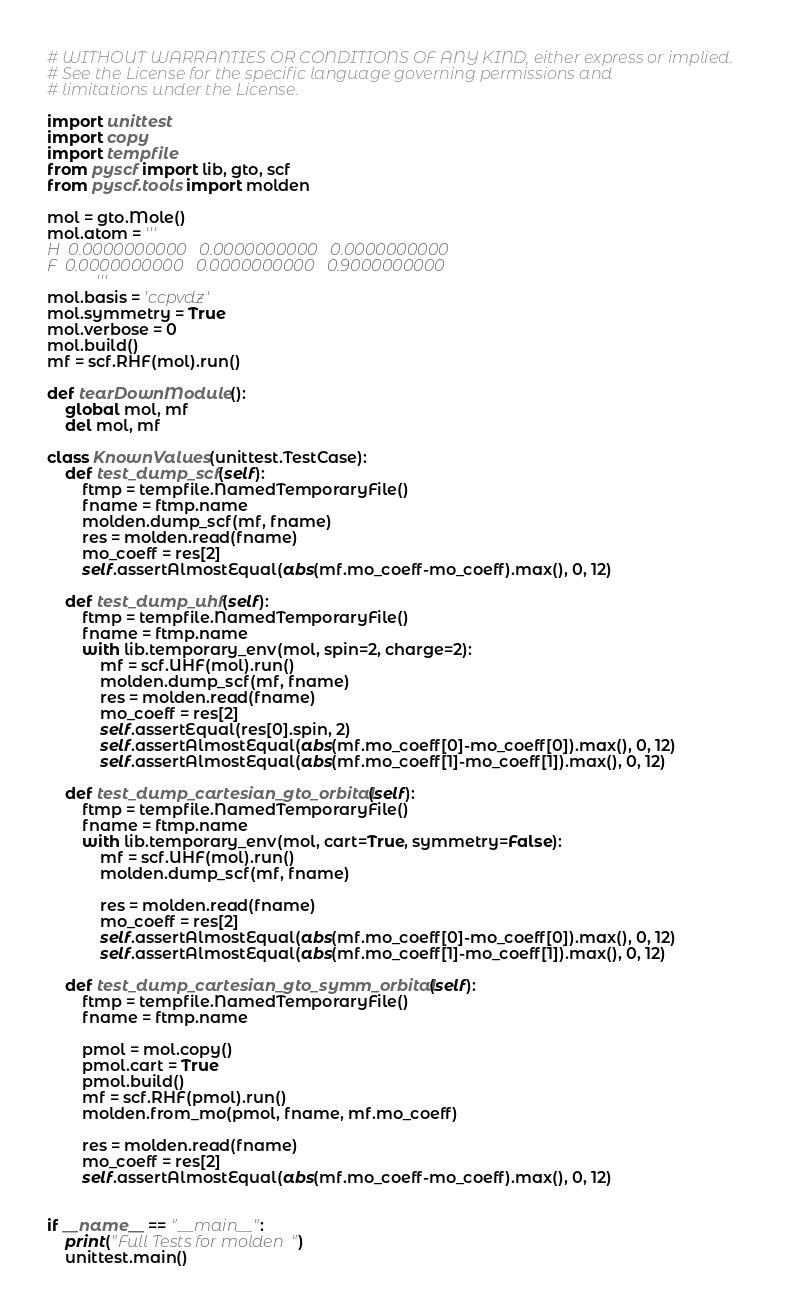<code> <loc_0><loc_0><loc_500><loc_500><_Python_># WITHOUT WARRANTIES OR CONDITIONS OF ANY KIND, either express or implied.
# See the License for the specific language governing permissions and
# limitations under the License.

import unittest
import copy
import tempfile
from pyscf import lib, gto, scf
from pyscf.tools import molden

mol = gto.Mole()
mol.atom = '''
H  0.0000000000   0.0000000000   0.0000000000
F  0.0000000000   0.0000000000   0.9000000000
           '''
mol.basis = 'ccpvdz'
mol.symmetry = True
mol.verbose = 0
mol.build()
mf = scf.RHF(mol).run()

def tearDownModule():
    global mol, mf
    del mol, mf

class KnownValues(unittest.TestCase):
    def test_dump_scf(self):
        ftmp = tempfile.NamedTemporaryFile()
        fname = ftmp.name
        molden.dump_scf(mf, fname)
        res = molden.read(fname)
        mo_coeff = res[2]
        self.assertAlmostEqual(abs(mf.mo_coeff-mo_coeff).max(), 0, 12)

    def test_dump_uhf(self):
        ftmp = tempfile.NamedTemporaryFile()
        fname = ftmp.name
        with lib.temporary_env(mol, spin=2, charge=2):
            mf = scf.UHF(mol).run()
            molden.dump_scf(mf, fname)
            res = molden.read(fname)
            mo_coeff = res[2]
            self.assertEqual(res[0].spin, 2)
            self.assertAlmostEqual(abs(mf.mo_coeff[0]-mo_coeff[0]).max(), 0, 12)
            self.assertAlmostEqual(abs(mf.mo_coeff[1]-mo_coeff[1]).max(), 0, 12)

    def test_dump_cartesian_gto_orbital(self):
        ftmp = tempfile.NamedTemporaryFile()
        fname = ftmp.name
        with lib.temporary_env(mol, cart=True, symmetry=False):
            mf = scf.UHF(mol).run()
            molden.dump_scf(mf, fname)

            res = molden.read(fname)
            mo_coeff = res[2]
            self.assertAlmostEqual(abs(mf.mo_coeff[0]-mo_coeff[0]).max(), 0, 12)
            self.assertAlmostEqual(abs(mf.mo_coeff[1]-mo_coeff[1]).max(), 0, 12)

    def test_dump_cartesian_gto_symm_orbital(self):
        ftmp = tempfile.NamedTemporaryFile()
        fname = ftmp.name

        pmol = mol.copy()
        pmol.cart = True
        pmol.build()
        mf = scf.RHF(pmol).run()
        molden.from_mo(pmol, fname, mf.mo_coeff)

        res = molden.read(fname)
        mo_coeff = res[2]
        self.assertAlmostEqual(abs(mf.mo_coeff-mo_coeff).max(), 0, 12)


if __name__ == "__main__":
    print("Full Tests for molden")
    unittest.main()



</code> 